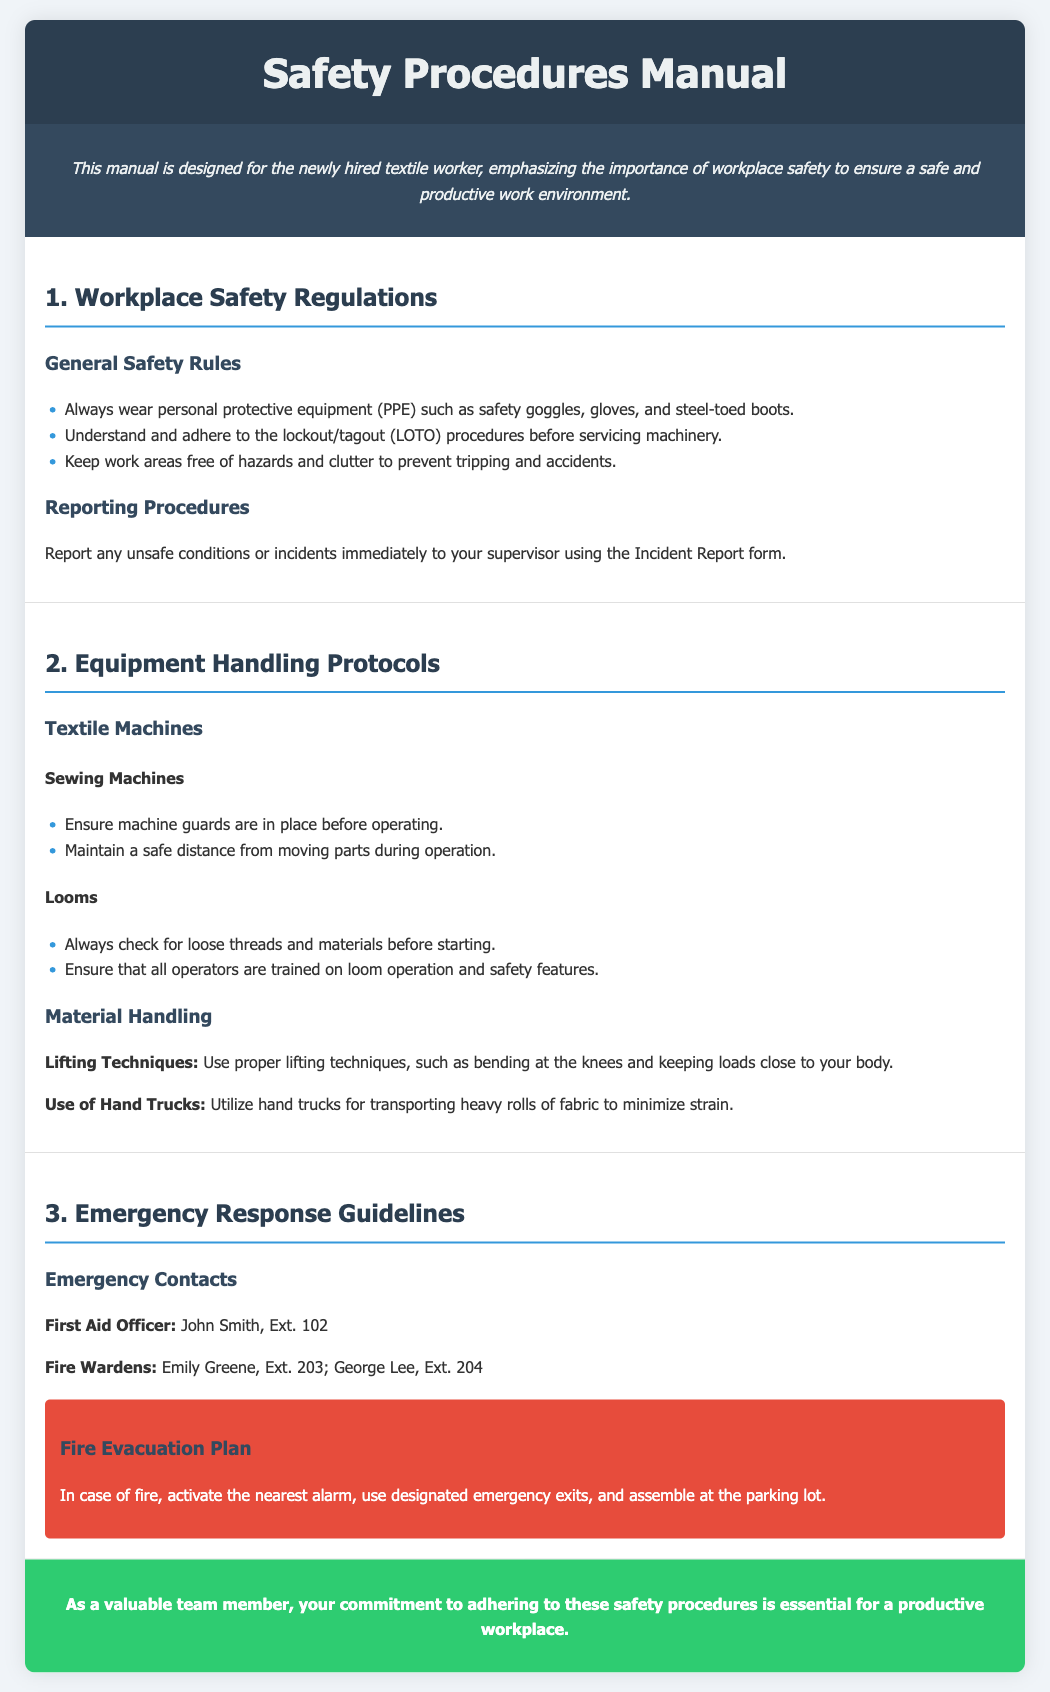what is the title of the document? The title of the document is mentioned in the header section.
Answer: Safety Procedures Manual who is the first aid officer? The document provides contact information for emergency contacts, including the first aid officer's name.
Answer: John Smith what should you always wear for protection? The general safety rules section lists the required personal protective equipment.
Answer: PPE what is the extension number for George Lee? The emergency contacts section provides specific extension numbers for fire wardens.
Answer: 204 what should be done before servicing machinery? The general safety rules emphasize a safety procedure that must be followed before maintenance.
Answer: Lockout/tagout procedures how should lifting be performed according to the manual? The equipment handling protocols section describes proper lifting techniques.
Answer: Bend at the knees where should employees assemble in case of fire? The fire evacuation plan indicates where employees should gather during a fire emergency.
Answer: Parking lot what equipment should have guards in place before operation? The section on textile machines specifies a safety requirement for a certain type of machine.
Answer: Sewing Machines who are the fire wardens listed? The emergency contacts section lists the names of individuals responsible for fire safety.
Answer: Emily Greene, George Lee 